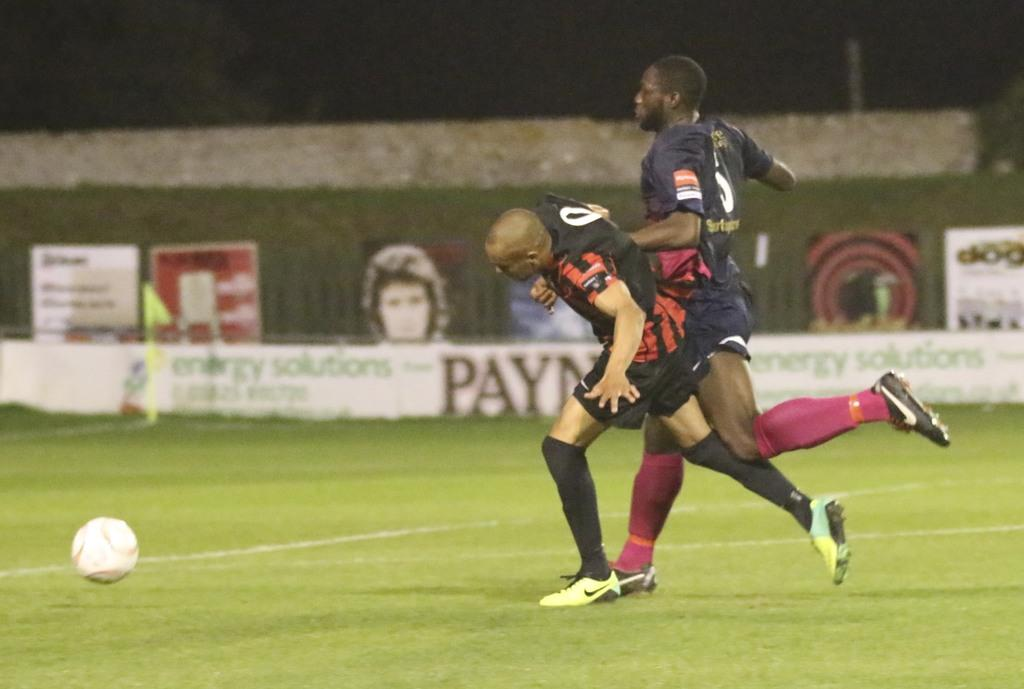How many people are in the image? There are two men in the image. What are the men doing in the image? The men are running on the ground. What object is present in the image besides the men? There is a ball in the image. What can be seen hanging or displayed in the image? There are banners in the image. What is the color of the background in the image? The background of the image is dark. What is the northernmost limit of the men's running path in the image? There is no information about the northernmost limit of the men's running path in the image. How much care do the men show for the ball while running in the image? There is no indication of the men's level of care for the ball in the image. 